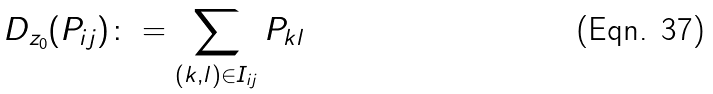<formula> <loc_0><loc_0><loc_500><loc_500>D _ { z _ { 0 } } ( P _ { i j } ) \colon = \sum _ { ( k , l ) \in I _ { i j } } P _ { k l }</formula> 